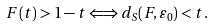<formula> <loc_0><loc_0><loc_500><loc_500>F ( t ) > 1 - t \Longleftrightarrow d _ { S } ( F , \varepsilon _ { 0 } ) < t .</formula> 